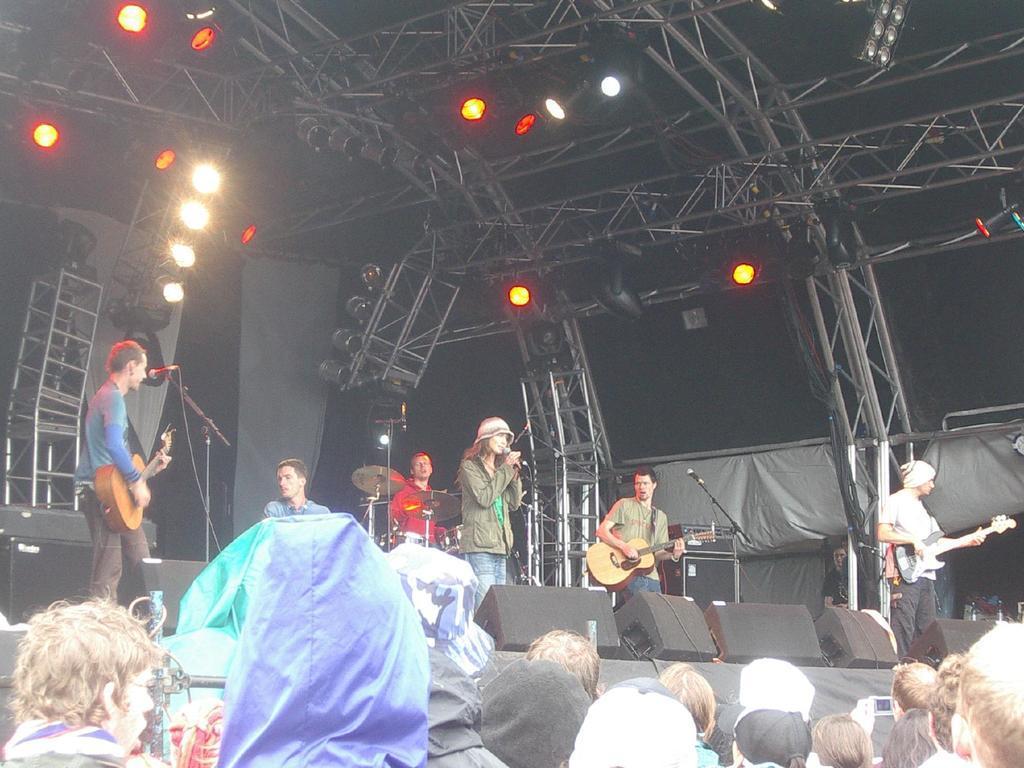In one or two sentences, can you explain what this image depicts? This image is clicked in a musical concert where there are lights on the top, there are speakers on the right and left there are people on the stage ,who are playing different musical instruments. One of them who is standing in the middle is singing, people are watching them who are in the bottom. 